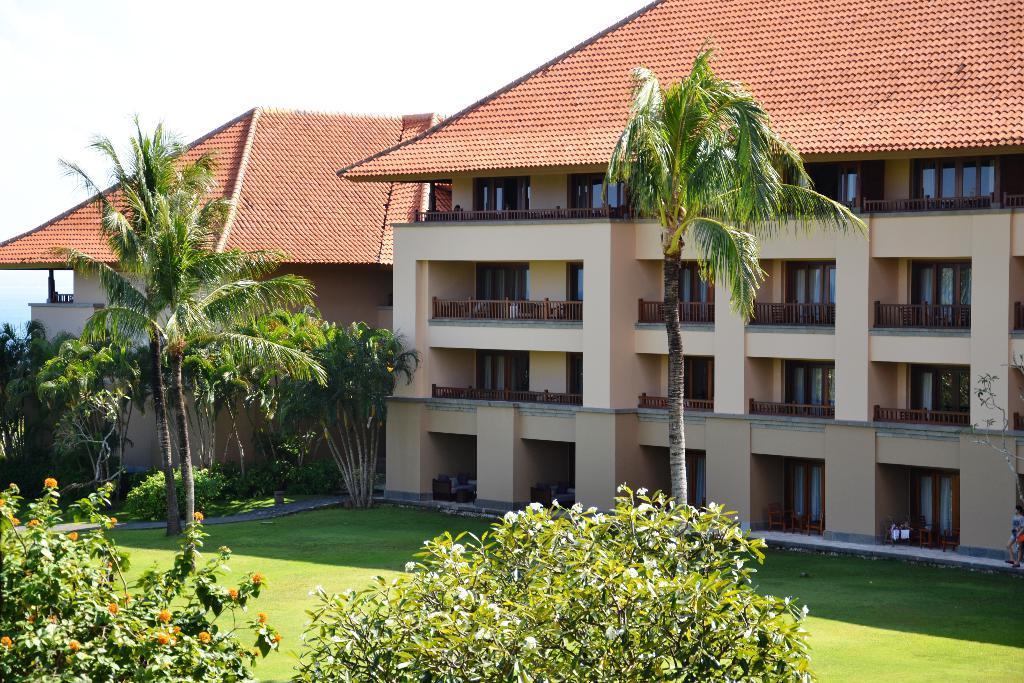How would you summarize this image in a sentence or two? In this picture I can see buildings, trees, plants and grass. On the ground floor I can see the table and chairs which are placed near to the doors. At the top I can see the sky. On the left I can see the water. 